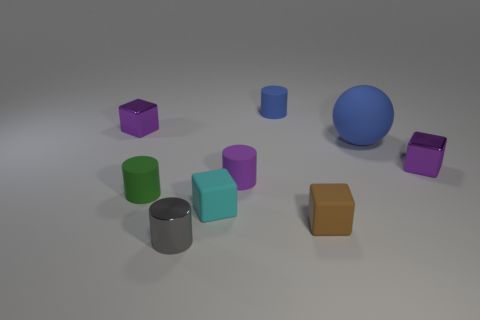Are there any other things that are the same shape as the large blue matte object?
Provide a succinct answer. No. How many blue things are either tiny metallic objects or large rubber objects?
Provide a short and direct response. 1. Are there more cylinders that are right of the gray metal cylinder than big green objects?
Make the answer very short. Yes. Is the size of the green thing the same as the cyan matte cube?
Your answer should be compact. Yes. What is the color of the ball that is made of the same material as the green thing?
Make the answer very short. Blue. What shape is the small thing that is the same color as the large rubber thing?
Keep it short and to the point. Cylinder. Are there the same number of small purple metallic things on the left side of the purple matte object and tiny purple blocks that are to the right of the large blue object?
Provide a short and direct response. Yes. The small purple metallic object that is behind the small purple cube on the right side of the small green cylinder is what shape?
Provide a succinct answer. Cube. What material is the small purple thing that is the same shape as the small blue matte thing?
Ensure brevity in your answer.  Rubber. There is a metal cylinder that is the same size as the brown matte block; what is its color?
Provide a short and direct response. Gray. 